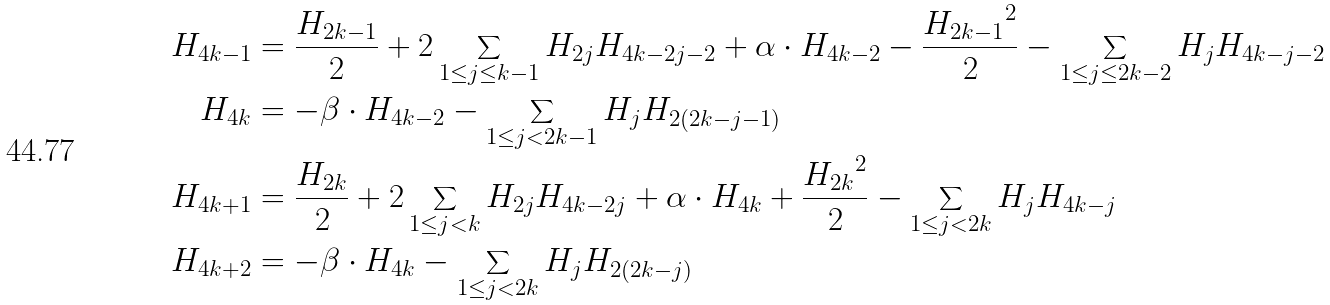Convert formula to latex. <formula><loc_0><loc_0><loc_500><loc_500>H _ { 4 k - 1 } & = \frac { H _ { 2 k - 1 } } { 2 } + 2 \sum _ { 1 \leq j \leq k - 1 } H _ { 2 j } H _ { 4 k - 2 j - 2 } + \alpha \cdot H _ { 4 k - 2 } - \frac { { H _ { 2 k - 1 } } ^ { 2 } } { 2 } - \sum _ { 1 \leq j \leq 2 k - 2 } H _ { j } H _ { 4 k - j - 2 } \\ H _ { 4 k } & = - \beta \cdot H _ { 4 k - 2 } - \sum _ { 1 \leq j < 2 k - 1 } H _ { j } H _ { 2 ( 2 k - j - 1 ) } \\ H _ { 4 k + 1 } & = \frac { H _ { 2 k } } { 2 } + 2 \sum _ { 1 \leq j < k } H _ { 2 j } H _ { 4 k - 2 j } + \alpha \cdot H _ { 4 k } + \frac { { H _ { 2 k } } ^ { 2 } } { 2 } - \sum _ { 1 \leq j < 2 k } H _ { j } H _ { 4 k - j } \\ H _ { 4 k + 2 } & = - \beta \cdot H _ { 4 k } - \sum _ { 1 \leq j < 2 k } H _ { j } H _ { 2 ( 2 k - j ) }</formula> 